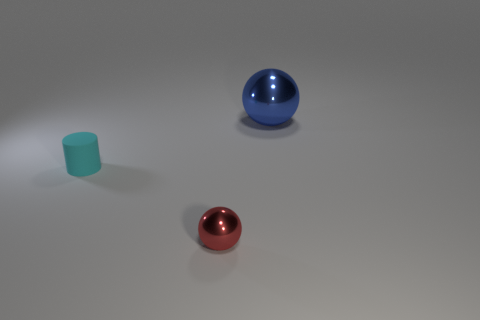Add 2 blue spheres. How many objects exist? 5 Subtract all spheres. How many objects are left? 1 Add 1 large blue shiny things. How many large blue shiny things are left? 2 Add 2 tiny red things. How many tiny red things exist? 3 Subtract 0 gray cubes. How many objects are left? 3 Subtract all balls. Subtract all rubber cylinders. How many objects are left? 0 